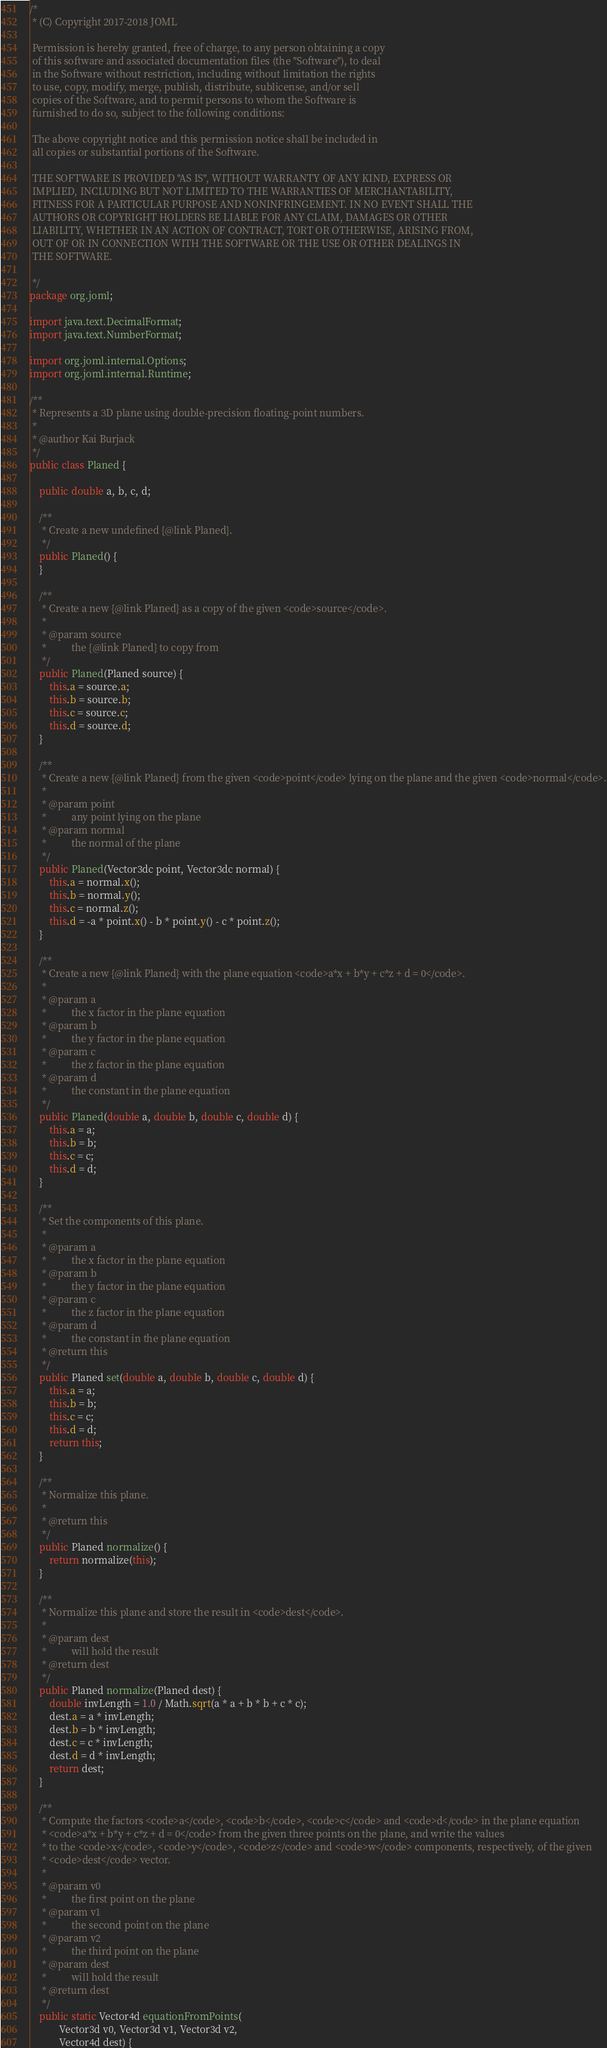Convert code to text. <code><loc_0><loc_0><loc_500><loc_500><_Java_>/*
 * (C) Copyright 2017-2018 JOML

 Permission is hereby granted, free of charge, to any person obtaining a copy
 of this software and associated documentation files (the "Software"), to deal
 in the Software without restriction, including without limitation the rights
 to use, copy, modify, merge, publish, distribute, sublicense, and/or sell
 copies of the Software, and to permit persons to whom the Software is
 furnished to do so, subject to the following conditions:

 The above copyright notice and this permission notice shall be included in
 all copies or substantial portions of the Software.

 THE SOFTWARE IS PROVIDED "AS IS", WITHOUT WARRANTY OF ANY KIND, EXPRESS OR
 IMPLIED, INCLUDING BUT NOT LIMITED TO THE WARRANTIES OF MERCHANTABILITY,
 FITNESS FOR A PARTICULAR PURPOSE AND NONINFRINGEMENT. IN NO EVENT SHALL THE
 AUTHORS OR COPYRIGHT HOLDERS BE LIABLE FOR ANY CLAIM, DAMAGES OR OTHER
 LIABILITY, WHETHER IN AN ACTION OF CONTRACT, TORT OR OTHERWISE, ARISING FROM,
 OUT OF OR IN CONNECTION WITH THE SOFTWARE OR THE USE OR OTHER DEALINGS IN
 THE SOFTWARE.

 */
package org.joml;

import java.text.DecimalFormat;
import java.text.NumberFormat;

import org.joml.internal.Options;
import org.joml.internal.Runtime;

/**
 * Represents a 3D plane using double-precision floating-point numbers.
 * 
 * @author Kai Burjack
 */
public class Planed {

    public double a, b, c, d;

    /**
     * Create a new undefined {@link Planed}.
     */
    public Planed() {
    }

    /**
     * Create a new {@link Planed} as a copy of the given <code>source</code>.
     * 
     * @param source
     *          the {@link Planed} to copy from
     */
    public Planed(Planed source) {
        this.a = source.a;
        this.b = source.b;
        this.c = source.c;
        this.d = source.d;
    }

    /**
     * Create a new {@link Planed} from the given <code>point</code> lying on the plane and the given <code>normal</code>.
     * 
     * @param point
     *          any point lying on the plane
     * @param normal
     *          the normal of the plane
     */
    public Planed(Vector3dc point, Vector3dc normal) {
        this.a = normal.x();
        this.b = normal.y();
        this.c = normal.z();
        this.d = -a * point.x() - b * point.y() - c * point.z();
    }

    /**
     * Create a new {@link Planed} with the plane equation <code>a*x + b*y + c*z + d = 0</code>.
     * 
     * @param a
     *          the x factor in the plane equation
     * @param b
     *          the y factor in the plane equation
     * @param c
     *          the z factor in the plane equation
     * @param d
     *          the constant in the plane equation
     */
    public Planed(double a, double b, double c, double d) {
        this.a = a;
        this.b = b;
        this.c = c;
        this.d = d;
    }

    /**
     * Set the components of this plane. 
     * 
     * @param a
     *          the x factor in the plane equation
     * @param b
     *          the y factor in the plane equation
     * @param c
     *          the z factor in the plane equation
     * @param d
     *          the constant in the plane equation
     * @return this
     */
    public Planed set(double a, double b, double c, double d) {
        this.a = a;
        this.b = b;
        this.c = c;
        this.d = d;
        return this;
    }

    /**
     * Normalize this plane.
     * 
     * @return this
     */
    public Planed normalize() {
        return normalize(this);
    }

    /**
     * Normalize this plane and store the result in <code>dest</code>.
     * 
     * @param dest
     *          will hold the result
     * @return dest
     */
    public Planed normalize(Planed dest) {
        double invLength = 1.0 / Math.sqrt(a * a + b * b + c * c);
        dest.a = a * invLength;
        dest.b = b * invLength;
        dest.c = c * invLength;
        dest.d = d * invLength;
        return dest;
    }

    /**
     * Compute the factors <code>a</code>, <code>b</code>, <code>c</code> and <code>d</code> in the plane equation
     * <code>a*x + b*y + c*z + d = 0</code> from the given three points on the plane, and write the values
     * to the <code>x</code>, <code>y</code>, <code>z</code> and <code>w</code> components, respectively, of the given
     * <code>dest</code> vector.
     * 
     * @param v0
     *          the first point on the plane
     * @param v1
     *          the second point on the plane
     * @param v2
     *          the third point on the plane
     * @param dest
     *          will hold the result
     * @return dest
     */
    public static Vector4d equationFromPoints(
            Vector3d v0, Vector3d v1, Vector3d v2,
            Vector4d dest) {</code> 